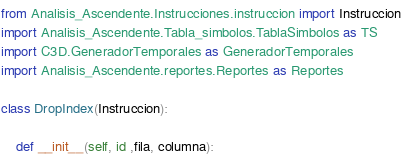Convert code to text. <code><loc_0><loc_0><loc_500><loc_500><_Python_>from Analisis_Ascendente.Instrucciones.instruccion import Instruccion
import Analisis_Ascendente.Tabla_simbolos.TablaSimbolos as TS
import C3D.GeneradorTemporales as GeneradorTemporales
import Analisis_Ascendente.reportes.Reportes as Reportes

class DropIndex(Instruccion):

    def __init__(self, id ,fila, columna):</code> 